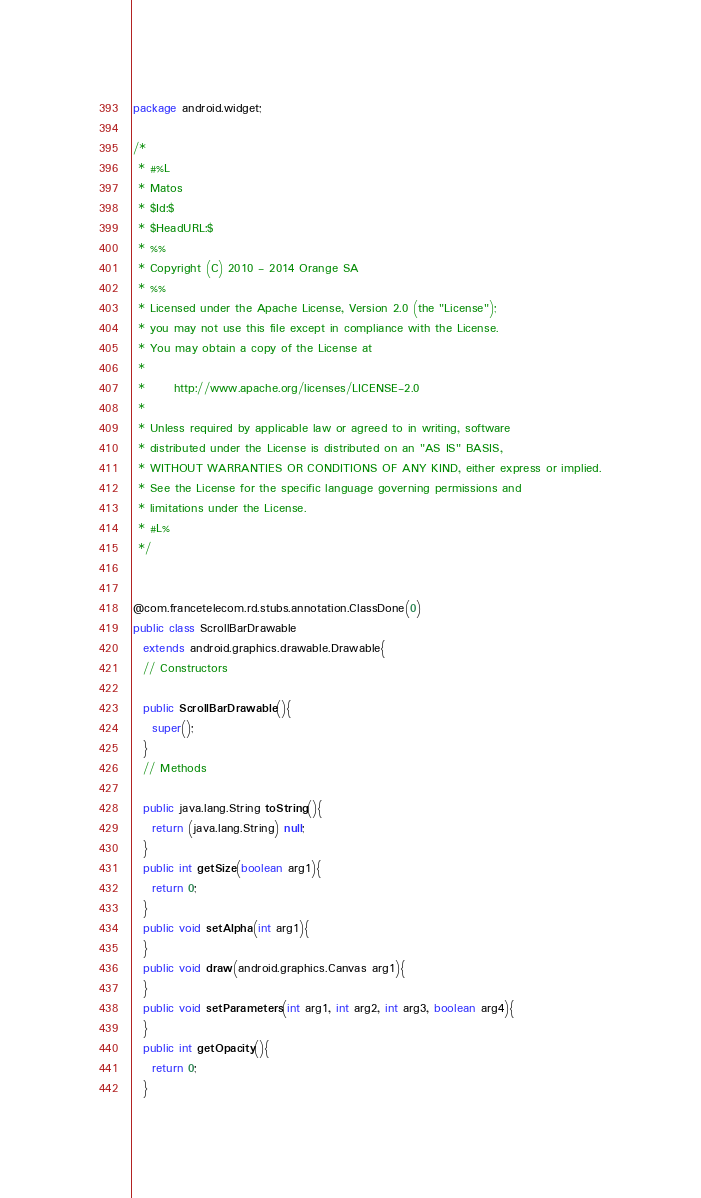Convert code to text. <code><loc_0><loc_0><loc_500><loc_500><_Java_>package android.widget;

/*
 * #%L
 * Matos
 * $Id:$
 * $HeadURL:$
 * %%
 * Copyright (C) 2010 - 2014 Orange SA
 * %%
 * Licensed under the Apache License, Version 2.0 (the "License");
 * you may not use this file except in compliance with the License.
 * You may obtain a copy of the License at
 * 
 *      http://www.apache.org/licenses/LICENSE-2.0
 * 
 * Unless required by applicable law or agreed to in writing, software
 * distributed under the License is distributed on an "AS IS" BASIS,
 * WITHOUT WARRANTIES OR CONDITIONS OF ANY KIND, either express or implied.
 * See the License for the specific language governing permissions and
 * limitations under the License.
 * #L%
 */


@com.francetelecom.rd.stubs.annotation.ClassDone(0)
public class ScrollBarDrawable
  extends android.graphics.drawable.Drawable{
  // Constructors

  public ScrollBarDrawable(){
    super();
  }
  // Methods

  public java.lang.String toString(){
    return (java.lang.String) null;
  }
  public int getSize(boolean arg1){
    return 0;
  }
  public void setAlpha(int arg1){
  }
  public void draw(android.graphics.Canvas arg1){
  }
  public void setParameters(int arg1, int arg2, int arg3, boolean arg4){
  }
  public int getOpacity(){
    return 0;
  }</code> 